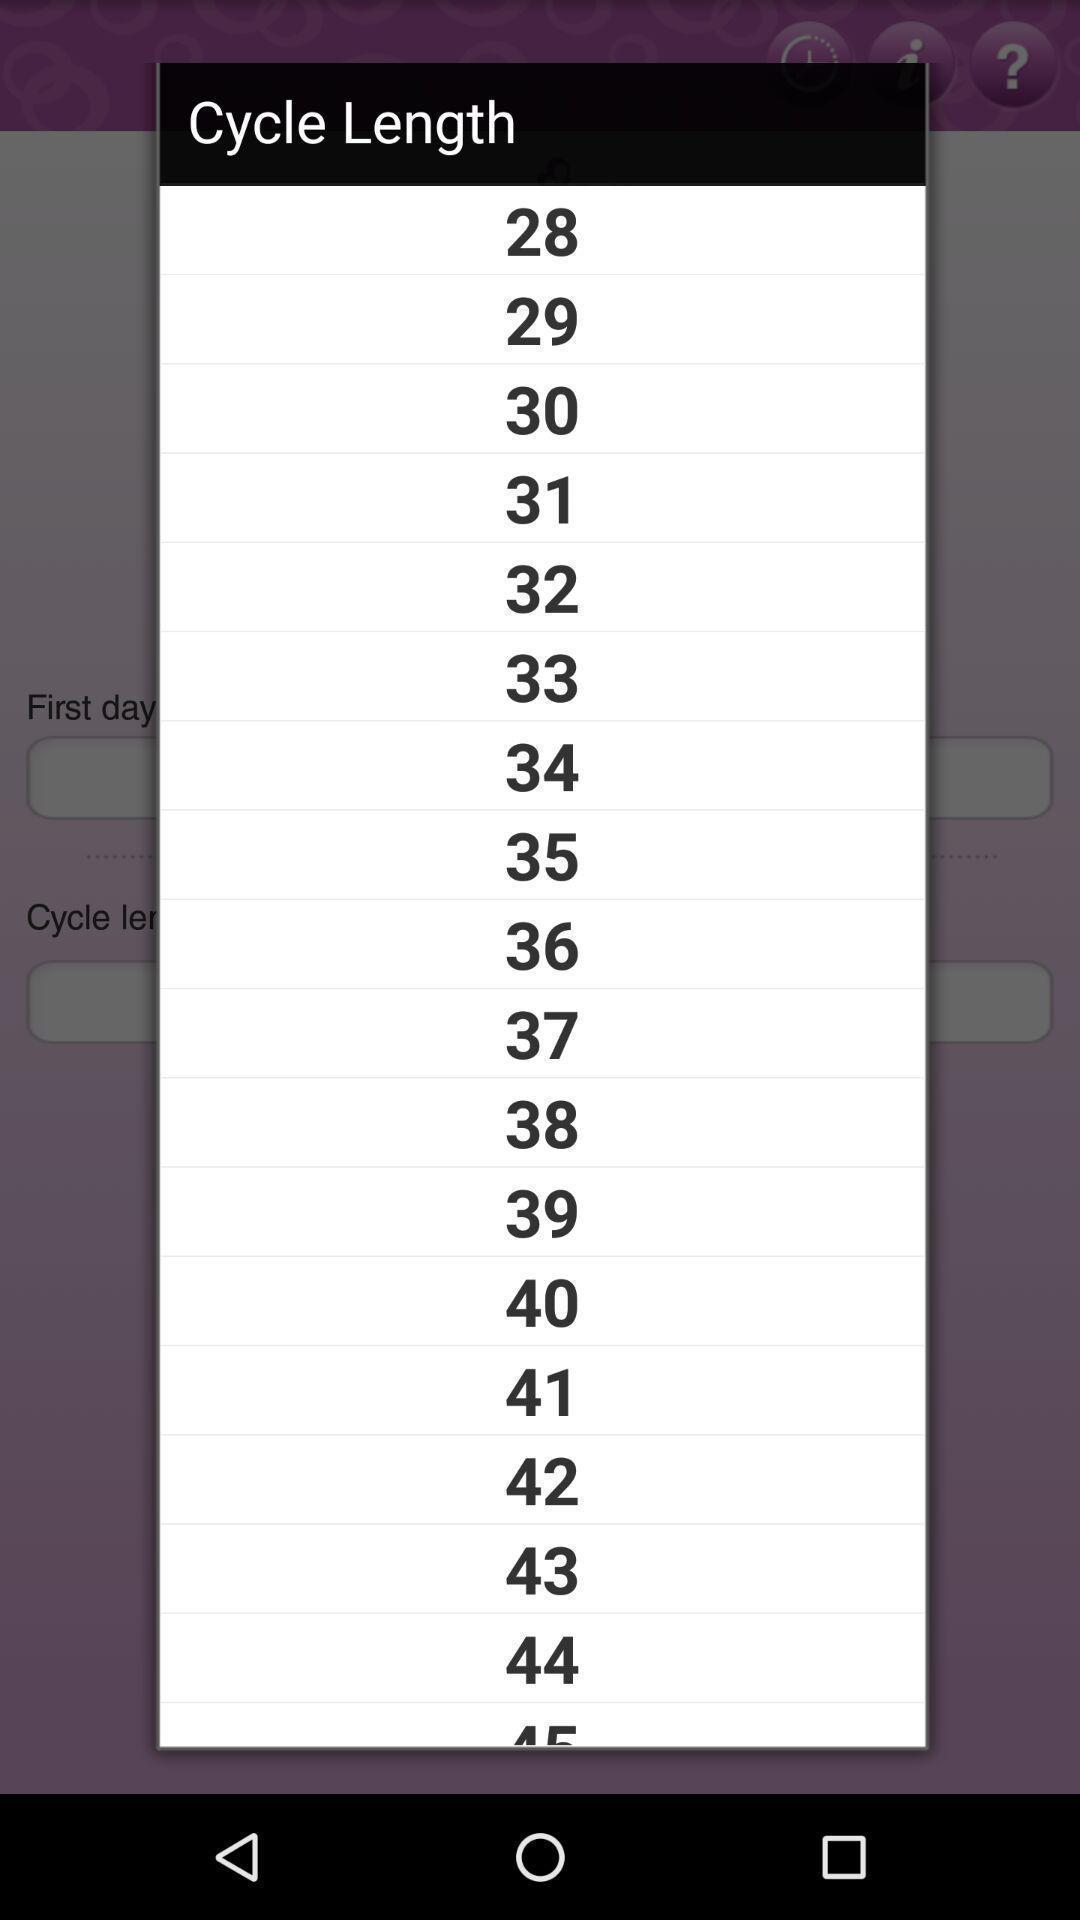Summarize the main components in this picture. Pop up showing list of cycle length. 